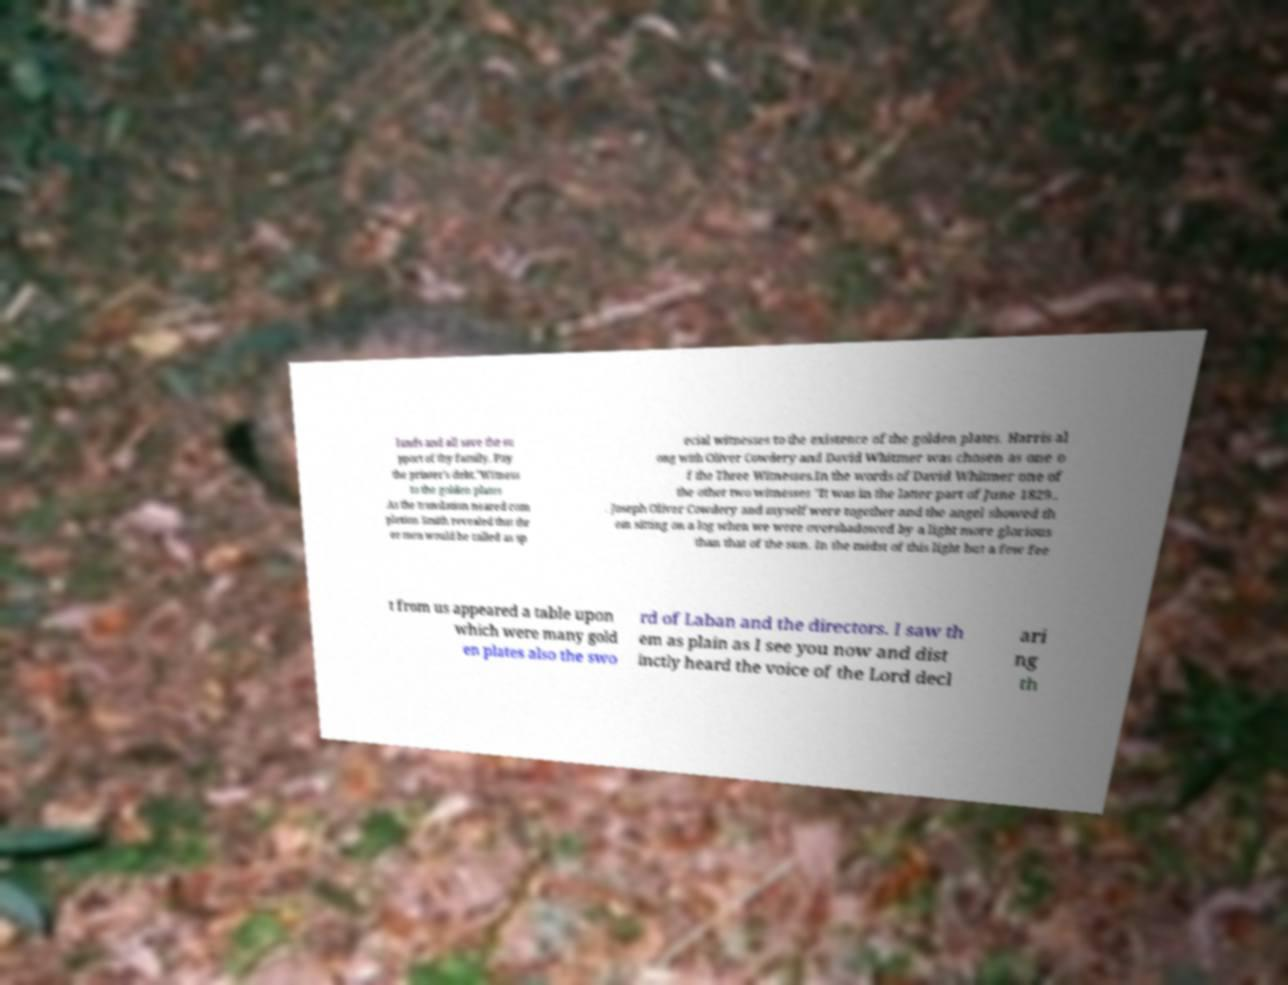I need the written content from this picture converted into text. Can you do that? lands and all save the su pport of thy family. Pay the printer's debt."Witness to the golden plates .As the translation neared com pletion Smith revealed that thr ee men would be called as sp ecial witnesses to the existence of the golden plates. Harris al ong with Oliver Cowdery and David Whitmer was chosen as one o f the Three Witnesses.In the words of David Whitmer one of the other two witnesses "It was in the latter part of June 1829.. . Joseph Oliver Cowdery and myself were together and the angel showed th em sitting on a log when we were overshadowed by a light more glorious than that of the sun. In the midst of this light but a few fee t from us appeared a table upon which were many gold en plates also the swo rd of Laban and the directors. I saw th em as plain as I see you now and dist inctly heard the voice of the Lord decl ari ng th 